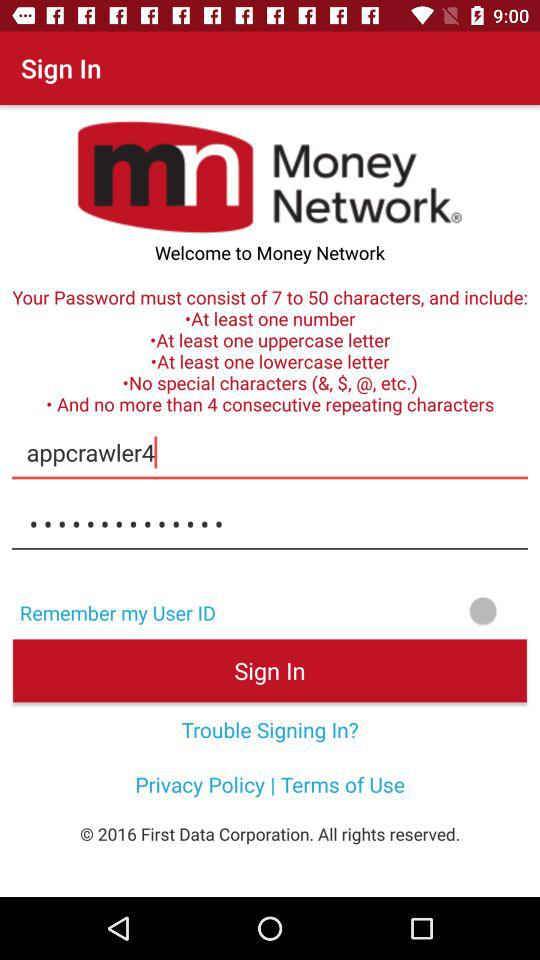What is the Email address?
When the provided information is insufficient, respond with <no answer>. <no answer> 